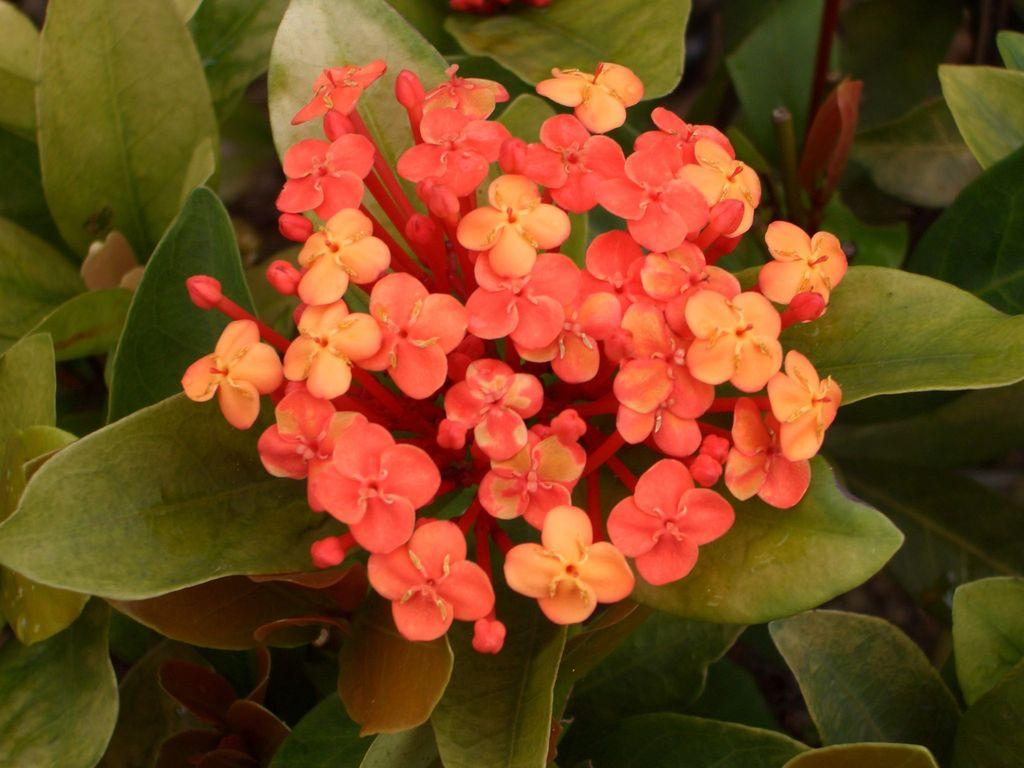What type of plants can be seen in the image? There are flowers and leaves in the image. Can you describe the specific characteristics of the plants in the image? The image features flowers and leaves, but it does not provide specific details about their characteristics. How many snakes are slithering among the flowers in the image? There are no snakes present in the image; it only features flowers and leaves. What is the fifth flower in the image? The image does not provide enough detail to identify individual flowers, let alone a specific one labeled as the fifth flower. 